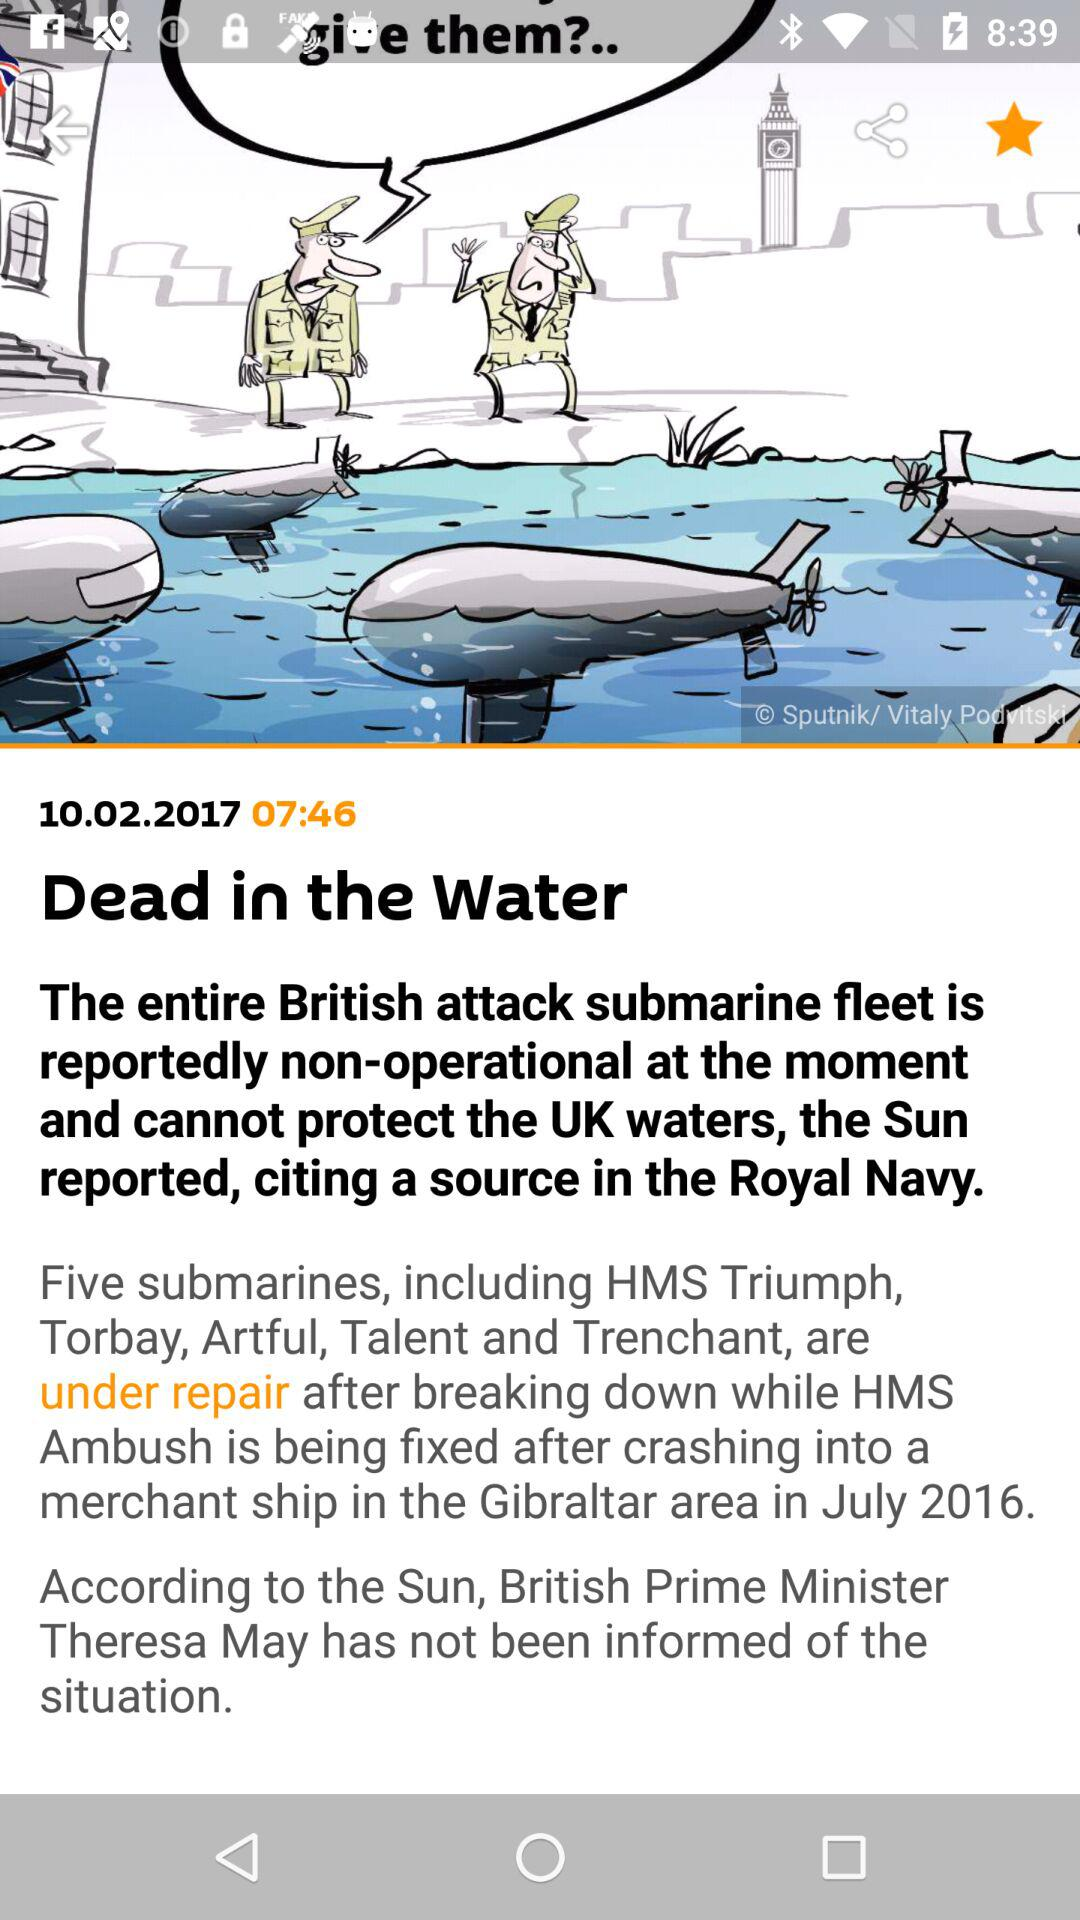What is the publication date of the article "Dead in the Water"? The publication date of the article "Dead in the Water" is October 2, 2017. 